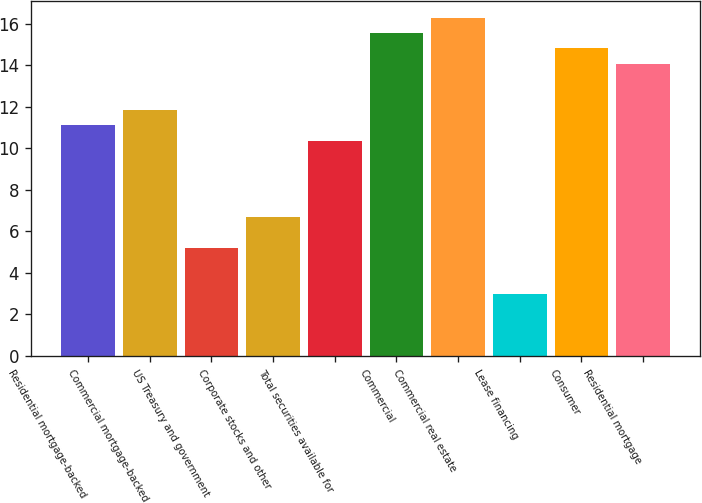<chart> <loc_0><loc_0><loc_500><loc_500><bar_chart><fcel>Residential mortgage-backed<fcel>Commercial mortgage-backed<fcel>US Treasury and government<fcel>Corporate stocks and other<fcel>Total securities available for<fcel>Commercial<fcel>Commercial real estate<fcel>Lease financing<fcel>Consumer<fcel>Residential mortgage<nl><fcel>11.11<fcel>11.85<fcel>5.19<fcel>6.67<fcel>10.37<fcel>15.55<fcel>16.29<fcel>2.97<fcel>14.81<fcel>14.07<nl></chart> 